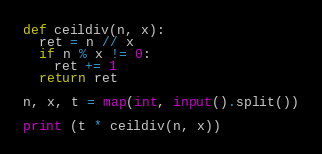Convert code to text. <code><loc_0><loc_0><loc_500><loc_500><_Python_>def ceildiv(n, x):
  ret = n // x
  if n % x != 0:
    ret += 1
  return ret

n, x, t = map(int, input().split())

print (t * ceildiv(n, x))</code> 